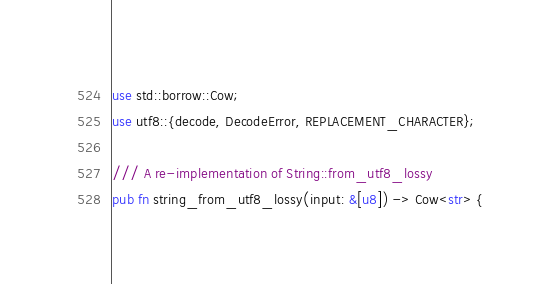<code> <loc_0><loc_0><loc_500><loc_500><_Rust_>use std::borrow::Cow;
use utf8::{decode, DecodeError, REPLACEMENT_CHARACTER};

/// A re-implementation of String::from_utf8_lossy
pub fn string_from_utf8_lossy(input: &[u8]) -> Cow<str> {</code> 